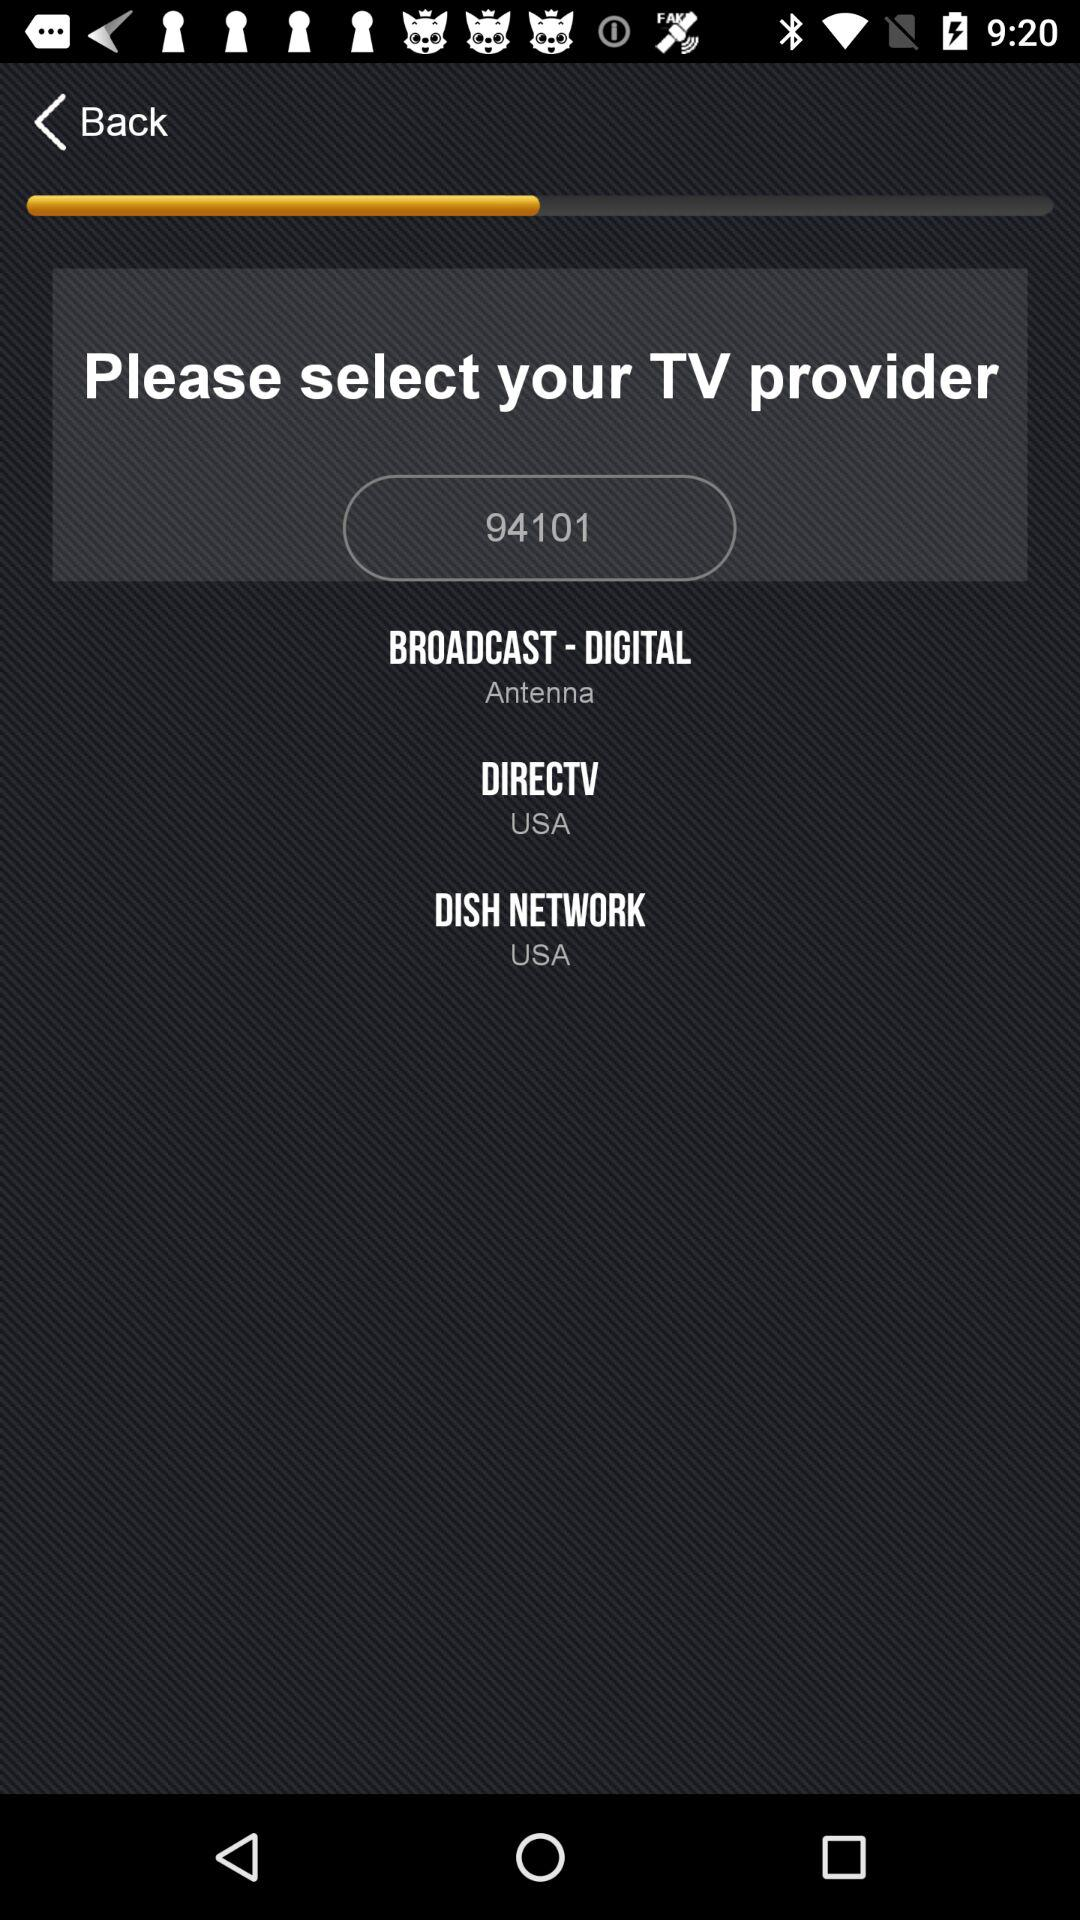Which directv is selected?
When the provided information is insufficient, respond with <no answer>. <no answer> 